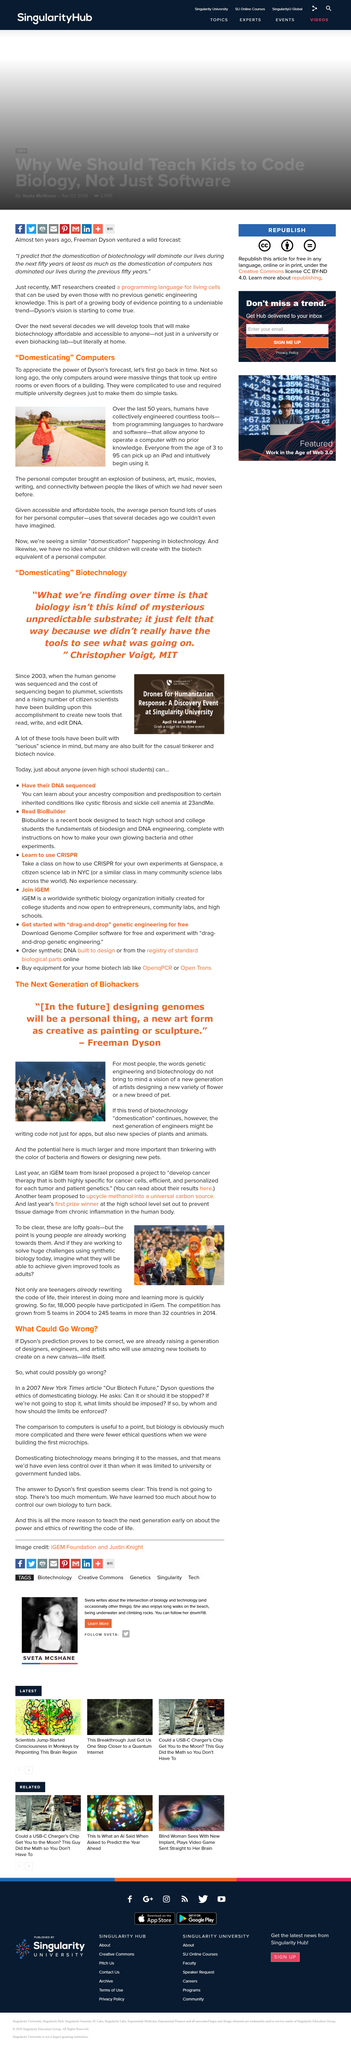List a handful of essential elements in this visual. It is true that the new generation of artists is creating a new variety of flower. Yes, the research's potential is significantly larger than designing new pets. A team of iGEM participants from Israel proposed a project aimed at developing a cancer therapy that is highly specific for cancer cells, efficient, and personalized for each patient's unique genetic makeup. As of now, a total of 18,000 individuals have participated in iGem. The iPad is suitable for use by individuals of all ages, ranging from 3 years old to 95 years old. 